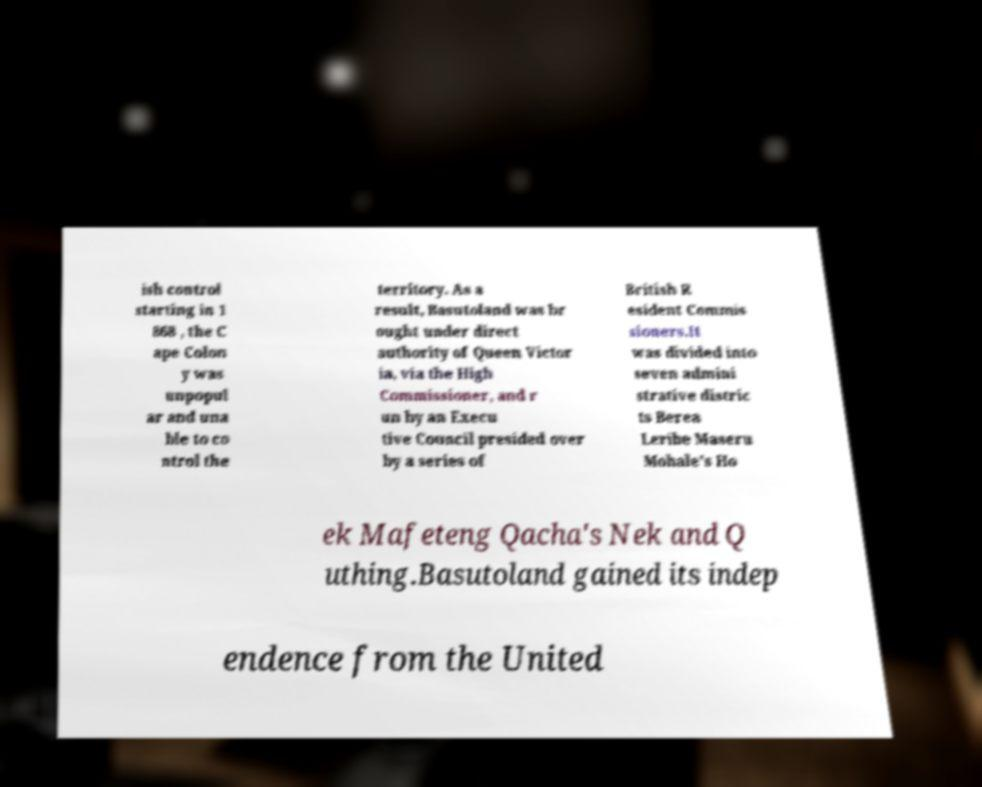Could you assist in decoding the text presented in this image and type it out clearly? ish control starting in 1 868 , the C ape Colon y was unpopul ar and una ble to co ntrol the territory. As a result, Basutoland was br ought under direct authority of Queen Victor ia, via the High Commissioner, and r un by an Execu tive Council presided over by a series of British R esident Commis sioners.It was divided into seven admini strative distric ts Berea Leribe Maseru Mohale's Ho ek Mafeteng Qacha's Nek and Q uthing.Basutoland gained its indep endence from the United 